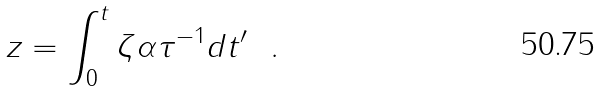<formula> <loc_0><loc_0><loc_500><loc_500>z = \int _ { 0 } ^ { t } \zeta \alpha \tau ^ { - 1 } d t ^ { \prime } \ \ .</formula> 